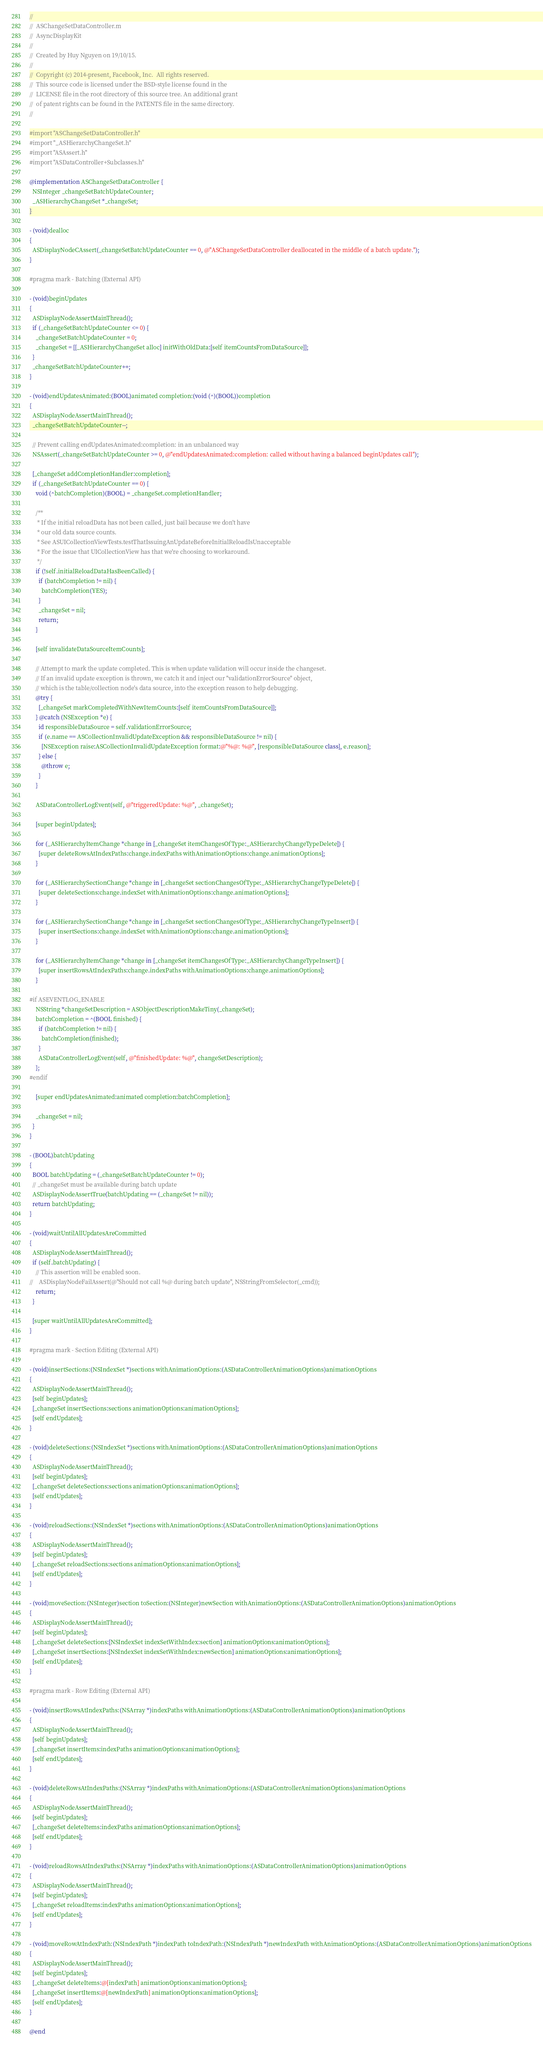<code> <loc_0><loc_0><loc_500><loc_500><_ObjectiveC_>//
//  ASChangeSetDataController.m
//  AsyncDisplayKit
//
//  Created by Huy Nguyen on 19/10/15.
//
//  Copyright (c) 2014-present, Facebook, Inc.  All rights reserved.
//  This source code is licensed under the BSD-style license found in the
//  LICENSE file in the root directory of this source tree. An additional grant
//  of patent rights can be found in the PATENTS file in the same directory.
//

#import "ASChangeSetDataController.h"
#import "_ASHierarchyChangeSet.h"
#import "ASAssert.h"
#import "ASDataController+Subclasses.h"

@implementation ASChangeSetDataController {
  NSInteger _changeSetBatchUpdateCounter;
  _ASHierarchyChangeSet *_changeSet;
}

- (void)dealloc
{
  ASDisplayNodeCAssert(_changeSetBatchUpdateCounter == 0, @"ASChangeSetDataController deallocated in the middle of a batch update.");
}

#pragma mark - Batching (External API)

- (void)beginUpdates
{
  ASDisplayNodeAssertMainThread();
  if (_changeSetBatchUpdateCounter <= 0) {
    _changeSetBatchUpdateCounter = 0;
    _changeSet = [[_ASHierarchyChangeSet alloc] initWithOldData:[self itemCountsFromDataSource]];
  }
  _changeSetBatchUpdateCounter++;
}

- (void)endUpdatesAnimated:(BOOL)animated completion:(void (^)(BOOL))completion
{
  ASDisplayNodeAssertMainThread();
  _changeSetBatchUpdateCounter--;
  
  // Prevent calling endUpdatesAnimated:completion: in an unbalanced way
  NSAssert(_changeSetBatchUpdateCounter >= 0, @"endUpdatesAnimated:completion: called without having a balanced beginUpdates call");
  
  [_changeSet addCompletionHandler:completion];
  if (_changeSetBatchUpdateCounter == 0) {
    void (^batchCompletion)(BOOL) = _changeSet.completionHandler;
    
    /**
     * If the initial reloadData has not been called, just bail because we don't have
     * our old data source counts.
     * See ASUICollectionViewTests.testThatIssuingAnUpdateBeforeInitialReloadIsUnacceptable
     * For the issue that UICollectionView has that we're choosing to workaround.
     */
    if (!self.initialReloadDataHasBeenCalled) {
      if (batchCompletion != nil) {
        batchCompletion(YES);
      }
      _changeSet = nil;
      return;
    }

    [self invalidateDataSourceItemCounts];

    // Attempt to mark the update completed. This is when update validation will occur inside the changeset.
    // If an invalid update exception is thrown, we catch it and inject our "validationErrorSource" object,
    // which is the table/collection node's data source, into the exception reason to help debugging.
    @try {
      [_changeSet markCompletedWithNewItemCounts:[self itemCountsFromDataSource]];
    } @catch (NSException *e) {
      id responsibleDataSource = self.validationErrorSource;
      if (e.name == ASCollectionInvalidUpdateException && responsibleDataSource != nil) {
        [NSException raise:ASCollectionInvalidUpdateException format:@"%@: %@", [responsibleDataSource class], e.reason];
      } else {
        @throw e;
      }
    }
    
    ASDataControllerLogEvent(self, @"triggeredUpdate: %@", _changeSet);
    
    [super beginUpdates];
    
    for (_ASHierarchyItemChange *change in [_changeSet itemChangesOfType:_ASHierarchyChangeTypeDelete]) {
      [super deleteRowsAtIndexPaths:change.indexPaths withAnimationOptions:change.animationOptions];
    }
    
    for (_ASHierarchySectionChange *change in [_changeSet sectionChangesOfType:_ASHierarchyChangeTypeDelete]) {
      [super deleteSections:change.indexSet withAnimationOptions:change.animationOptions];
    }
    
    for (_ASHierarchySectionChange *change in [_changeSet sectionChangesOfType:_ASHierarchyChangeTypeInsert]) {
      [super insertSections:change.indexSet withAnimationOptions:change.animationOptions];
    }
    
    for (_ASHierarchyItemChange *change in [_changeSet itemChangesOfType:_ASHierarchyChangeTypeInsert]) {
      [super insertRowsAtIndexPaths:change.indexPaths withAnimationOptions:change.animationOptions];
    }

#if ASEVENTLOG_ENABLE
    NSString *changeSetDescription = ASObjectDescriptionMakeTiny(_changeSet);
    batchCompletion = ^(BOOL finished) {
      if (batchCompletion != nil) {
        batchCompletion(finished);
      }
      ASDataControllerLogEvent(self, @"finishedUpdate: %@", changeSetDescription);
    };
#endif
    
    [super endUpdatesAnimated:animated completion:batchCompletion];
    
    _changeSet = nil;
  }
}

- (BOOL)batchUpdating
{
  BOOL batchUpdating = (_changeSetBatchUpdateCounter != 0);
  // _changeSet must be available during batch update
  ASDisplayNodeAssertTrue(batchUpdating == (_changeSet != nil));
  return batchUpdating;
}

- (void)waitUntilAllUpdatesAreCommitted
{
  ASDisplayNodeAssertMainThread();
  if (self.batchUpdating) {
    // This assertion will be enabled soon.
//    ASDisplayNodeFailAssert(@"Should not call %@ during batch update", NSStringFromSelector(_cmd));
    return;
  }

  [super waitUntilAllUpdatesAreCommitted];
}

#pragma mark - Section Editing (External API)

- (void)insertSections:(NSIndexSet *)sections withAnimationOptions:(ASDataControllerAnimationOptions)animationOptions
{
  ASDisplayNodeAssertMainThread();
  [self beginUpdates];
  [_changeSet insertSections:sections animationOptions:animationOptions];
  [self endUpdates];
}

- (void)deleteSections:(NSIndexSet *)sections withAnimationOptions:(ASDataControllerAnimationOptions)animationOptions
{
  ASDisplayNodeAssertMainThread();
  [self beginUpdates];
  [_changeSet deleteSections:sections animationOptions:animationOptions];
  [self endUpdates];
}

- (void)reloadSections:(NSIndexSet *)sections withAnimationOptions:(ASDataControllerAnimationOptions)animationOptions
{
  ASDisplayNodeAssertMainThread();
  [self beginUpdates];
  [_changeSet reloadSections:sections animationOptions:animationOptions];
  [self endUpdates];
}

- (void)moveSection:(NSInteger)section toSection:(NSInteger)newSection withAnimationOptions:(ASDataControllerAnimationOptions)animationOptions
{
  ASDisplayNodeAssertMainThread();
  [self beginUpdates];
  [_changeSet deleteSections:[NSIndexSet indexSetWithIndex:section] animationOptions:animationOptions];
  [_changeSet insertSections:[NSIndexSet indexSetWithIndex:newSection] animationOptions:animationOptions];
  [self endUpdates];
}

#pragma mark - Row Editing (External API)

- (void)insertRowsAtIndexPaths:(NSArray *)indexPaths withAnimationOptions:(ASDataControllerAnimationOptions)animationOptions
{
  ASDisplayNodeAssertMainThread();
  [self beginUpdates];
  [_changeSet insertItems:indexPaths animationOptions:animationOptions];
  [self endUpdates];
}

- (void)deleteRowsAtIndexPaths:(NSArray *)indexPaths withAnimationOptions:(ASDataControllerAnimationOptions)animationOptions
{
  ASDisplayNodeAssertMainThread();
  [self beginUpdates];
  [_changeSet deleteItems:indexPaths animationOptions:animationOptions];
  [self endUpdates];
}

- (void)reloadRowsAtIndexPaths:(NSArray *)indexPaths withAnimationOptions:(ASDataControllerAnimationOptions)animationOptions
{
  ASDisplayNodeAssertMainThread();
  [self beginUpdates];
  [_changeSet reloadItems:indexPaths animationOptions:animationOptions];
  [self endUpdates];
}

- (void)moveRowAtIndexPath:(NSIndexPath *)indexPath toIndexPath:(NSIndexPath *)newIndexPath withAnimationOptions:(ASDataControllerAnimationOptions)animationOptions
{
  ASDisplayNodeAssertMainThread();
  [self beginUpdates];
  [_changeSet deleteItems:@[indexPath] animationOptions:animationOptions];
  [_changeSet insertItems:@[newIndexPath] animationOptions:animationOptions];
  [self endUpdates];
}

@end
</code> 